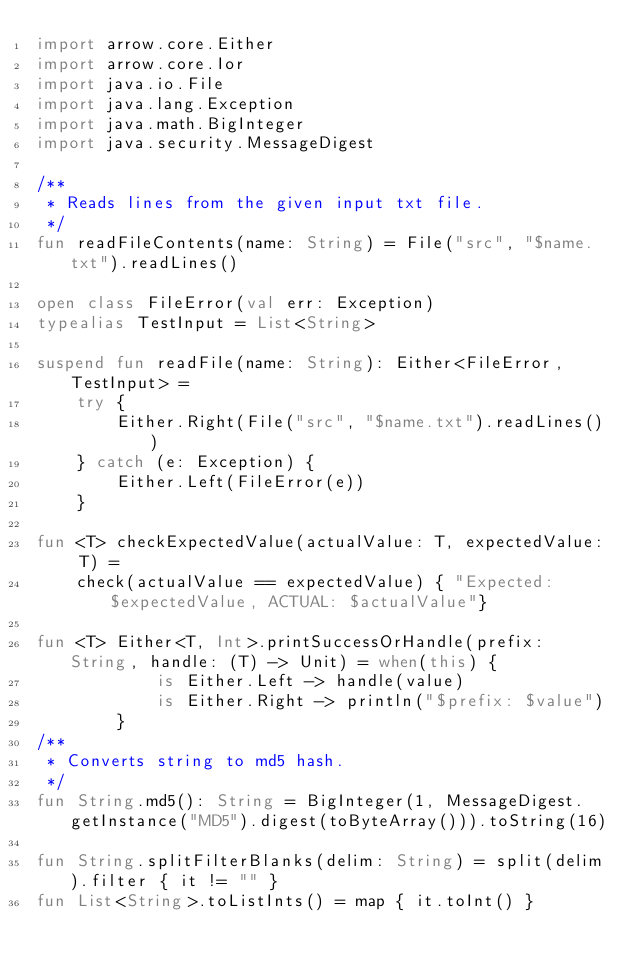<code> <loc_0><loc_0><loc_500><loc_500><_Kotlin_>import arrow.core.Either
import arrow.core.Ior
import java.io.File
import java.lang.Exception
import java.math.BigInteger
import java.security.MessageDigest

/**
 * Reads lines from the given input txt file.
 */
fun readFileContents(name: String) = File("src", "$name.txt").readLines()

open class FileError(val err: Exception)
typealias TestInput = List<String>

suspend fun readFile(name: String): Either<FileError, TestInput> =
    try {
        Either.Right(File("src", "$name.txt").readLines())
    } catch (e: Exception) {
        Either.Left(FileError(e))
    }

fun <T> checkExpectedValue(actualValue: T, expectedValue: T) =
    check(actualValue == expectedValue) { "Expected: $expectedValue, ACTUAL: $actualValue"}

fun <T> Either<T, Int>.printSuccessOrHandle(prefix: String, handle: (T) -> Unit) = when(this) {
            is Either.Left -> handle(value)
            is Either.Right -> println("$prefix: $value")
        }
/**
 * Converts string to md5 hash.
 */
fun String.md5(): String = BigInteger(1, MessageDigest.getInstance("MD5").digest(toByteArray())).toString(16)

fun String.splitFilterBlanks(delim: String) = split(delim).filter { it != "" }
fun List<String>.toListInts() = map { it.toInt() }</code> 